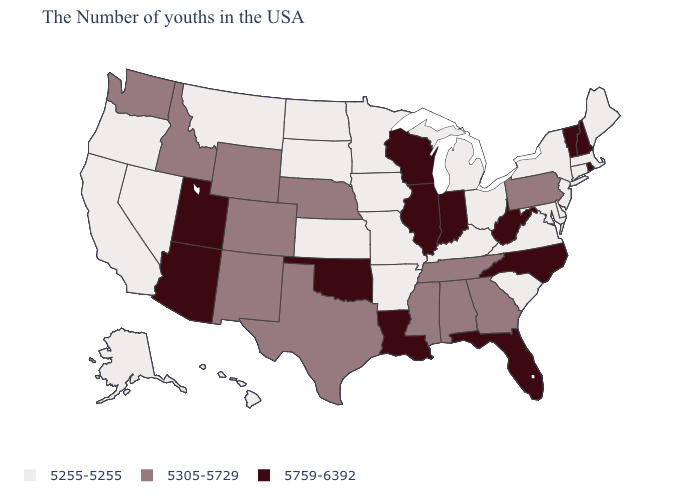Which states have the lowest value in the Northeast?
Concise answer only. Maine, Massachusetts, Connecticut, New York, New Jersey. What is the highest value in the USA?
Concise answer only. 5759-6392. Name the states that have a value in the range 5305-5729?
Give a very brief answer. Pennsylvania, Georgia, Alabama, Tennessee, Mississippi, Nebraska, Texas, Wyoming, Colorado, New Mexico, Idaho, Washington. What is the value of California?
Give a very brief answer. 5255-5255. Does the first symbol in the legend represent the smallest category?
Be succinct. Yes. Name the states that have a value in the range 5759-6392?
Quick response, please. Rhode Island, New Hampshire, Vermont, North Carolina, West Virginia, Florida, Indiana, Wisconsin, Illinois, Louisiana, Oklahoma, Utah, Arizona. Name the states that have a value in the range 5255-5255?
Give a very brief answer. Maine, Massachusetts, Connecticut, New York, New Jersey, Delaware, Maryland, Virginia, South Carolina, Ohio, Michigan, Kentucky, Missouri, Arkansas, Minnesota, Iowa, Kansas, South Dakota, North Dakota, Montana, Nevada, California, Oregon, Alaska, Hawaii. Among the states that border Missouri , which have the lowest value?
Give a very brief answer. Kentucky, Arkansas, Iowa, Kansas. Name the states that have a value in the range 5255-5255?
Quick response, please. Maine, Massachusetts, Connecticut, New York, New Jersey, Delaware, Maryland, Virginia, South Carolina, Ohio, Michigan, Kentucky, Missouri, Arkansas, Minnesota, Iowa, Kansas, South Dakota, North Dakota, Montana, Nevada, California, Oregon, Alaska, Hawaii. Does New York have a lower value than Connecticut?
Concise answer only. No. Which states have the lowest value in the USA?
Concise answer only. Maine, Massachusetts, Connecticut, New York, New Jersey, Delaware, Maryland, Virginia, South Carolina, Ohio, Michigan, Kentucky, Missouri, Arkansas, Minnesota, Iowa, Kansas, South Dakota, North Dakota, Montana, Nevada, California, Oregon, Alaska, Hawaii. Name the states that have a value in the range 5255-5255?
Write a very short answer. Maine, Massachusetts, Connecticut, New York, New Jersey, Delaware, Maryland, Virginia, South Carolina, Ohio, Michigan, Kentucky, Missouri, Arkansas, Minnesota, Iowa, Kansas, South Dakota, North Dakota, Montana, Nevada, California, Oregon, Alaska, Hawaii. Is the legend a continuous bar?
Be succinct. No. How many symbols are there in the legend?
Write a very short answer. 3. What is the lowest value in states that border Wyoming?
Write a very short answer. 5255-5255. 